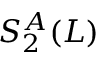<formula> <loc_0><loc_0><loc_500><loc_500>S _ { 2 } ^ { A } ( L )</formula> 